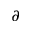<formula> <loc_0><loc_0><loc_500><loc_500>\partial</formula> 